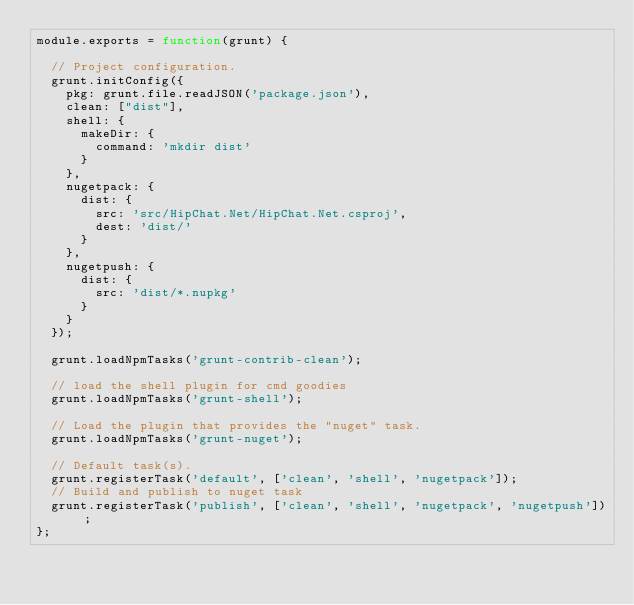<code> <loc_0><loc_0><loc_500><loc_500><_JavaScript_>module.exports = function(grunt) {

  // Project configuration.
  grunt.initConfig({
    pkg: grunt.file.readJSON('package.json'),
    clean: ["dist"],
    shell: {
      makeDir: {
        command: 'mkdir dist'
      }
    },
    nugetpack: {
      dist: {
        src: 'src/HipChat.Net/HipChat.Net.csproj',
        dest: 'dist/'
      }
    },
    nugetpush: {
      dist: {
        src: 'dist/*.nupkg'
      }
    }  
  });

  grunt.loadNpmTasks('grunt-contrib-clean');

  // load the shell plugin for cmd goodies
  grunt.loadNpmTasks('grunt-shell');

  // Load the plugin that provides the "nuget" task.
  grunt.loadNpmTasks('grunt-nuget');

  // Default task(s).
  grunt.registerTask('default', ['clean', 'shell', 'nugetpack']);
  // Build and publish to nuget task
  grunt.registerTask('publish', ['clean', 'shell', 'nugetpack', 'nugetpush']);
};</code> 